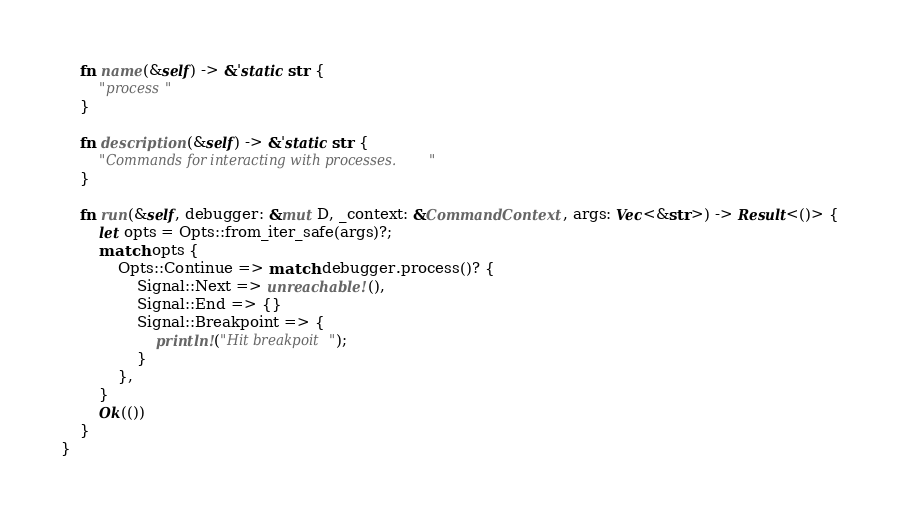Convert code to text. <code><loc_0><loc_0><loc_500><loc_500><_Rust_>    fn name(&self) -> &'static str {
        "process"
    }

    fn description(&self) -> &'static str {
        "Commands for interacting with processes."
    }

    fn run(&self, debugger: &mut D, _context: &CommandContext, args: Vec<&str>) -> Result<()> {
        let opts = Opts::from_iter_safe(args)?;
        match opts {
            Opts::Continue => match debugger.process()? {
                Signal::Next => unreachable!(),
                Signal::End => {}
                Signal::Breakpoint => {
                    println!("Hit breakpoit");
                }
            },
        }
        Ok(())
    }
}
</code> 